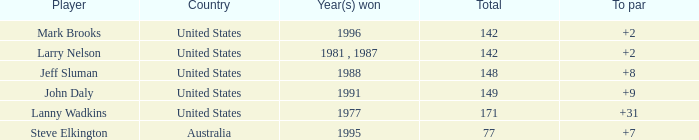Can you provide the overall total of jeff sluman? 148.0. 